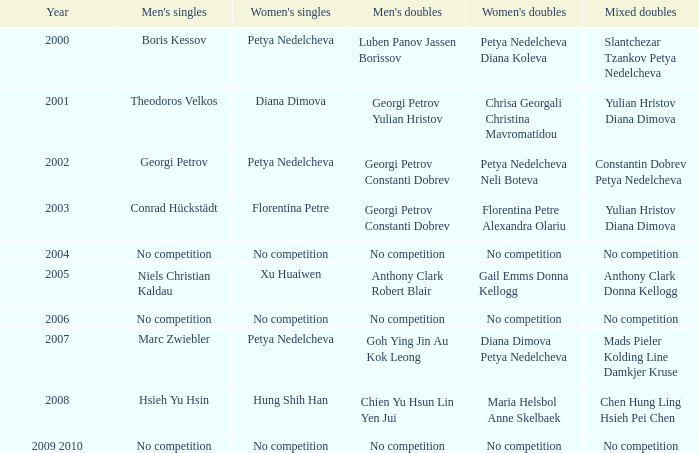Who won the Men's Double the same year as Florentina Petre winning the Women's Singles? Georgi Petrov Constanti Dobrev. 